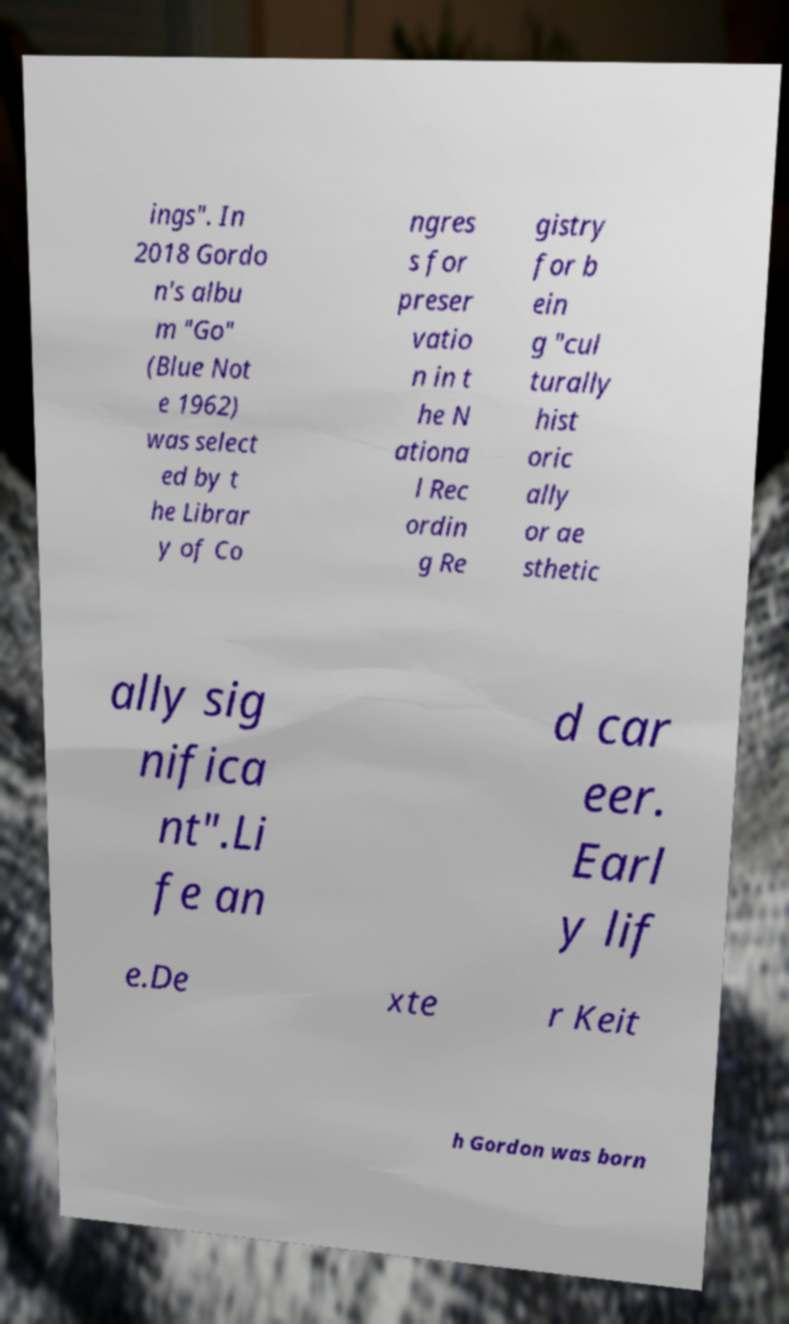What messages or text are displayed in this image? I need them in a readable, typed format. ings". In 2018 Gordo n's albu m "Go" (Blue Not e 1962) was select ed by t he Librar y of Co ngres s for preser vatio n in t he N ationa l Rec ordin g Re gistry for b ein g "cul turally hist oric ally or ae sthetic ally sig nifica nt".Li fe an d car eer. Earl y lif e.De xte r Keit h Gordon was born 